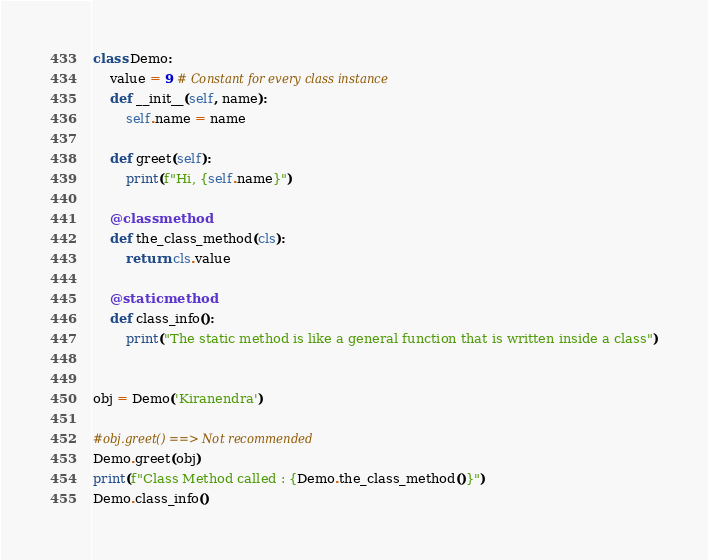Convert code to text. <code><loc_0><loc_0><loc_500><loc_500><_Python_>class Demo:
    value = 9 # Constant for every class instance
    def __init__(self, name):
        self.name = name

    def greet(self):
        print(f"Hi, {self.name}")

    @classmethod
    def the_class_method(cls):
        return cls.value

    @staticmethod
    def class_info():
        print("The static method is like a general function that is written inside a class")


obj = Demo('Kiranendra')

#obj.greet() ==> Not recommended
Demo.greet(obj)
print(f"Class Method called : {Demo.the_class_method()}")
Demo.class_info()

</code> 